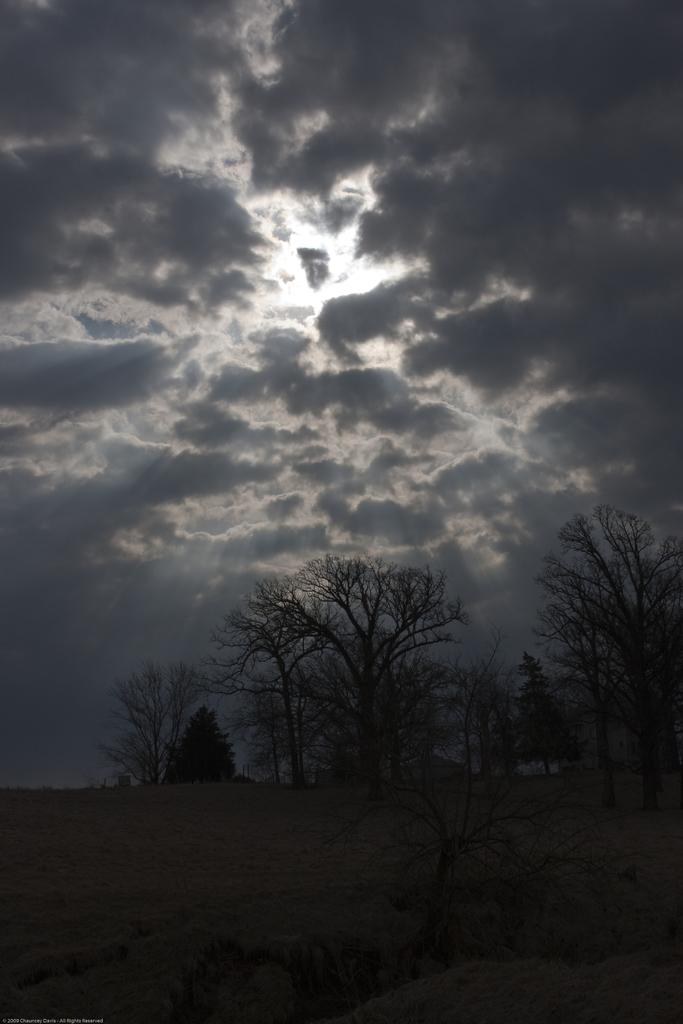What type of vegetation can be seen in the image? There are trees in the image. What is visible at the top of the image? The sky is visible at the top of the image. What can be observed in the sky? There are clouds in the sky. What type of fruit is hanging from the trees in the image? There is no fruit visible on the trees in the image. Can you tell me how many copies of the sweater are present in the image? There is no sweater present in the image. 